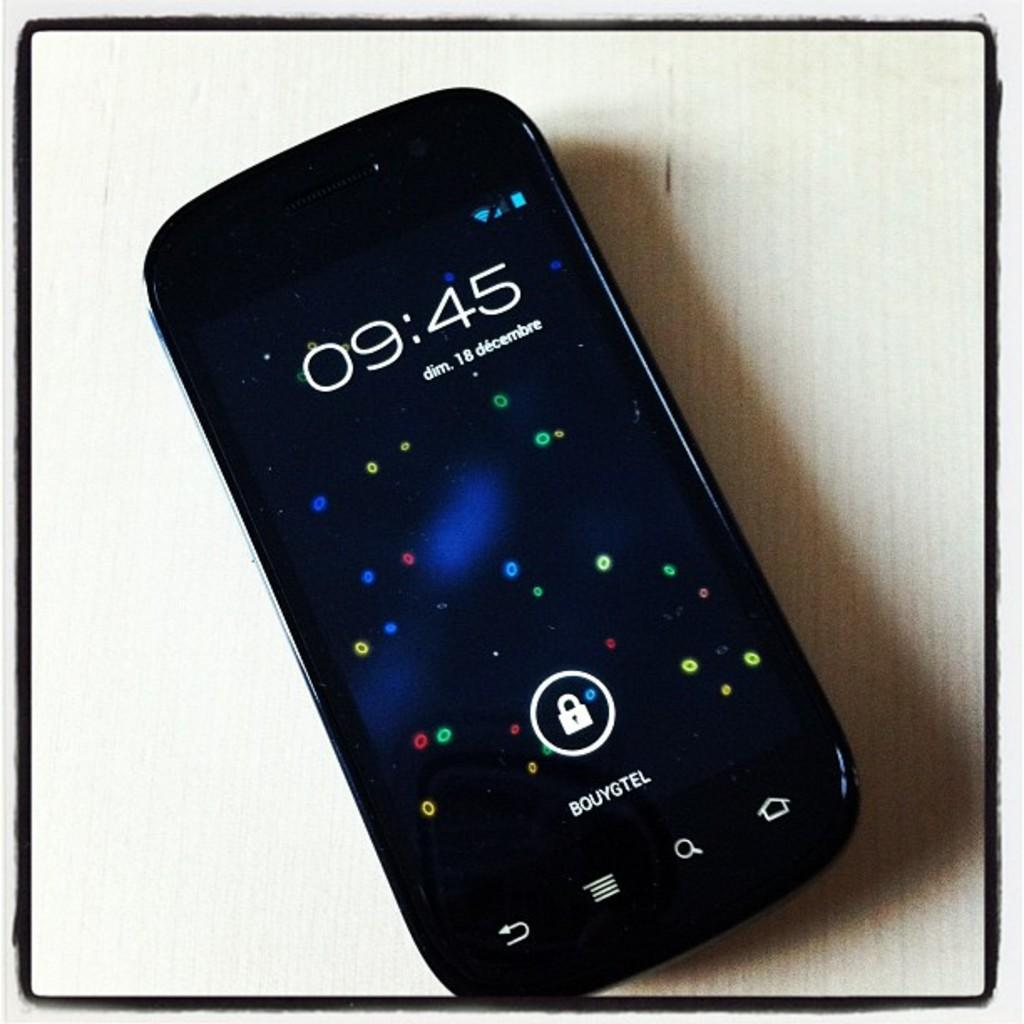Provide a one-sentence caption for the provided image. A cell phone displays the time 09:45 on its screen. 